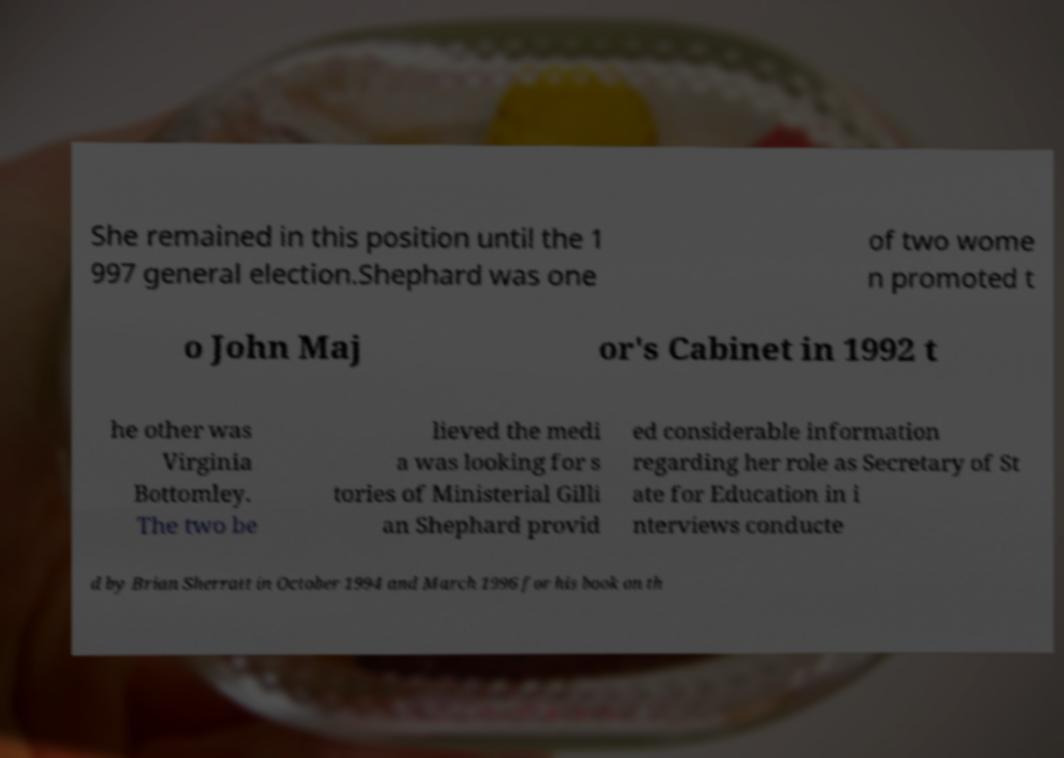For documentation purposes, I need the text within this image transcribed. Could you provide that? She remained in this position until the 1 997 general election.Shephard was one of two wome n promoted t o John Maj or's Cabinet in 1992 t he other was Virginia Bottomley. The two be lieved the medi a was looking for s tories of Ministerial Gilli an Shephard provid ed considerable information regarding her role as Secretary of St ate for Education in i nterviews conducte d by Brian Sherratt in October 1994 and March 1996 for his book on th 